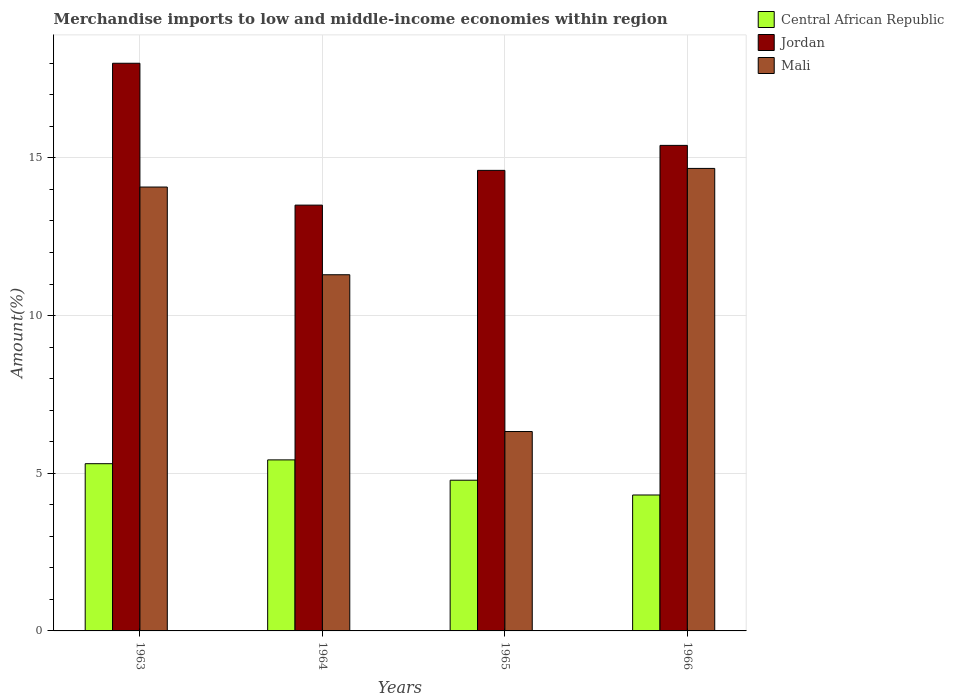How many groups of bars are there?
Your answer should be very brief. 4. Are the number of bars per tick equal to the number of legend labels?
Make the answer very short. Yes. Are the number of bars on each tick of the X-axis equal?
Keep it short and to the point. Yes. How many bars are there on the 1st tick from the right?
Provide a succinct answer. 3. What is the label of the 2nd group of bars from the left?
Offer a very short reply. 1964. In how many cases, is the number of bars for a given year not equal to the number of legend labels?
Make the answer very short. 0. What is the percentage of amount earned from merchandise imports in Jordan in 1965?
Ensure brevity in your answer.  14.6. Across all years, what is the maximum percentage of amount earned from merchandise imports in Jordan?
Make the answer very short. 18. Across all years, what is the minimum percentage of amount earned from merchandise imports in Central African Republic?
Your response must be concise. 4.31. In which year was the percentage of amount earned from merchandise imports in Central African Republic maximum?
Make the answer very short. 1964. In which year was the percentage of amount earned from merchandise imports in Jordan minimum?
Offer a terse response. 1964. What is the total percentage of amount earned from merchandise imports in Mali in the graph?
Give a very brief answer. 46.36. What is the difference between the percentage of amount earned from merchandise imports in Mali in 1963 and that in 1966?
Provide a succinct answer. -0.59. What is the difference between the percentage of amount earned from merchandise imports in Jordan in 1965 and the percentage of amount earned from merchandise imports in Central African Republic in 1963?
Provide a short and direct response. 9.3. What is the average percentage of amount earned from merchandise imports in Central African Republic per year?
Your answer should be very brief. 4.95. In the year 1966, what is the difference between the percentage of amount earned from merchandise imports in Central African Republic and percentage of amount earned from merchandise imports in Jordan?
Provide a short and direct response. -11.09. What is the ratio of the percentage of amount earned from merchandise imports in Mali in 1963 to that in 1966?
Provide a short and direct response. 0.96. Is the percentage of amount earned from merchandise imports in Jordan in 1964 less than that in 1965?
Make the answer very short. Yes. Is the difference between the percentage of amount earned from merchandise imports in Central African Republic in 1963 and 1966 greater than the difference between the percentage of amount earned from merchandise imports in Jordan in 1963 and 1966?
Your answer should be compact. No. What is the difference between the highest and the second highest percentage of amount earned from merchandise imports in Jordan?
Provide a succinct answer. 2.6. What is the difference between the highest and the lowest percentage of amount earned from merchandise imports in Mali?
Your answer should be compact. 8.34. In how many years, is the percentage of amount earned from merchandise imports in Central African Republic greater than the average percentage of amount earned from merchandise imports in Central African Republic taken over all years?
Offer a very short reply. 2. What does the 2nd bar from the left in 1964 represents?
Your answer should be very brief. Jordan. What does the 2nd bar from the right in 1964 represents?
Keep it short and to the point. Jordan. Is it the case that in every year, the sum of the percentage of amount earned from merchandise imports in Central African Republic and percentage of amount earned from merchandise imports in Mali is greater than the percentage of amount earned from merchandise imports in Jordan?
Provide a short and direct response. No. How many bars are there?
Give a very brief answer. 12. Are the values on the major ticks of Y-axis written in scientific E-notation?
Your answer should be compact. No. Does the graph contain any zero values?
Provide a short and direct response. No. Where does the legend appear in the graph?
Make the answer very short. Top right. How are the legend labels stacked?
Ensure brevity in your answer.  Vertical. What is the title of the graph?
Your answer should be compact. Merchandise imports to low and middle-income economies within region. Does "Macedonia" appear as one of the legend labels in the graph?
Ensure brevity in your answer.  No. What is the label or title of the Y-axis?
Make the answer very short. Amount(%). What is the Amount(%) in Central African Republic in 1963?
Offer a very short reply. 5.3. What is the Amount(%) of Jordan in 1963?
Keep it short and to the point. 18. What is the Amount(%) of Mali in 1963?
Your answer should be compact. 14.08. What is the Amount(%) in Central African Republic in 1964?
Give a very brief answer. 5.42. What is the Amount(%) in Jordan in 1964?
Make the answer very short. 13.5. What is the Amount(%) of Mali in 1964?
Provide a succinct answer. 11.29. What is the Amount(%) in Central African Republic in 1965?
Your response must be concise. 4.78. What is the Amount(%) of Jordan in 1965?
Make the answer very short. 14.6. What is the Amount(%) of Mali in 1965?
Your answer should be very brief. 6.32. What is the Amount(%) in Central African Republic in 1966?
Provide a short and direct response. 4.31. What is the Amount(%) of Jordan in 1966?
Offer a terse response. 15.4. What is the Amount(%) in Mali in 1966?
Make the answer very short. 14.67. Across all years, what is the maximum Amount(%) in Central African Republic?
Offer a terse response. 5.42. Across all years, what is the maximum Amount(%) of Jordan?
Make the answer very short. 18. Across all years, what is the maximum Amount(%) of Mali?
Provide a short and direct response. 14.67. Across all years, what is the minimum Amount(%) of Central African Republic?
Offer a terse response. 4.31. Across all years, what is the minimum Amount(%) of Jordan?
Your answer should be compact. 13.5. Across all years, what is the minimum Amount(%) of Mali?
Provide a succinct answer. 6.32. What is the total Amount(%) of Central African Republic in the graph?
Your response must be concise. 19.82. What is the total Amount(%) of Jordan in the graph?
Provide a succinct answer. 61.51. What is the total Amount(%) in Mali in the graph?
Offer a terse response. 46.36. What is the difference between the Amount(%) of Central African Republic in 1963 and that in 1964?
Your response must be concise. -0.12. What is the difference between the Amount(%) in Jordan in 1963 and that in 1964?
Make the answer very short. 4.5. What is the difference between the Amount(%) in Mali in 1963 and that in 1964?
Give a very brief answer. 2.78. What is the difference between the Amount(%) in Central African Republic in 1963 and that in 1965?
Give a very brief answer. 0.52. What is the difference between the Amount(%) in Jordan in 1963 and that in 1965?
Your answer should be very brief. 3.4. What is the difference between the Amount(%) of Mali in 1963 and that in 1965?
Offer a terse response. 7.75. What is the difference between the Amount(%) of Jordan in 1963 and that in 1966?
Your answer should be compact. 2.6. What is the difference between the Amount(%) of Mali in 1963 and that in 1966?
Offer a terse response. -0.59. What is the difference between the Amount(%) of Central African Republic in 1964 and that in 1965?
Your response must be concise. 0.64. What is the difference between the Amount(%) in Jordan in 1964 and that in 1965?
Give a very brief answer. -1.1. What is the difference between the Amount(%) of Mali in 1964 and that in 1965?
Ensure brevity in your answer.  4.97. What is the difference between the Amount(%) in Central African Republic in 1964 and that in 1966?
Provide a short and direct response. 1.11. What is the difference between the Amount(%) of Jordan in 1964 and that in 1966?
Give a very brief answer. -1.89. What is the difference between the Amount(%) in Mali in 1964 and that in 1966?
Give a very brief answer. -3.37. What is the difference between the Amount(%) in Central African Republic in 1965 and that in 1966?
Make the answer very short. 0.47. What is the difference between the Amount(%) in Jordan in 1965 and that in 1966?
Ensure brevity in your answer.  -0.79. What is the difference between the Amount(%) in Mali in 1965 and that in 1966?
Your answer should be compact. -8.34. What is the difference between the Amount(%) in Central African Republic in 1963 and the Amount(%) in Jordan in 1964?
Keep it short and to the point. -8.2. What is the difference between the Amount(%) in Central African Republic in 1963 and the Amount(%) in Mali in 1964?
Your answer should be very brief. -5.99. What is the difference between the Amount(%) of Jordan in 1963 and the Amount(%) of Mali in 1964?
Your answer should be compact. 6.71. What is the difference between the Amount(%) in Central African Republic in 1963 and the Amount(%) in Jordan in 1965?
Your answer should be compact. -9.3. What is the difference between the Amount(%) of Central African Republic in 1963 and the Amount(%) of Mali in 1965?
Offer a terse response. -1.02. What is the difference between the Amount(%) of Jordan in 1963 and the Amount(%) of Mali in 1965?
Keep it short and to the point. 11.68. What is the difference between the Amount(%) in Central African Republic in 1963 and the Amount(%) in Jordan in 1966?
Provide a succinct answer. -10.09. What is the difference between the Amount(%) in Central African Republic in 1963 and the Amount(%) in Mali in 1966?
Ensure brevity in your answer.  -9.36. What is the difference between the Amount(%) of Jordan in 1963 and the Amount(%) of Mali in 1966?
Provide a short and direct response. 3.33. What is the difference between the Amount(%) in Central African Republic in 1964 and the Amount(%) in Jordan in 1965?
Offer a very short reply. -9.18. What is the difference between the Amount(%) in Central African Republic in 1964 and the Amount(%) in Mali in 1965?
Give a very brief answer. -0.9. What is the difference between the Amount(%) of Jordan in 1964 and the Amount(%) of Mali in 1965?
Your response must be concise. 7.18. What is the difference between the Amount(%) in Central African Republic in 1964 and the Amount(%) in Jordan in 1966?
Provide a short and direct response. -9.97. What is the difference between the Amount(%) in Central African Republic in 1964 and the Amount(%) in Mali in 1966?
Make the answer very short. -9.24. What is the difference between the Amount(%) in Jordan in 1964 and the Amount(%) in Mali in 1966?
Offer a very short reply. -1.16. What is the difference between the Amount(%) in Central African Republic in 1965 and the Amount(%) in Jordan in 1966?
Your response must be concise. -10.62. What is the difference between the Amount(%) of Central African Republic in 1965 and the Amount(%) of Mali in 1966?
Keep it short and to the point. -9.89. What is the difference between the Amount(%) in Jordan in 1965 and the Amount(%) in Mali in 1966?
Keep it short and to the point. -0.06. What is the average Amount(%) in Central African Republic per year?
Your answer should be compact. 4.95. What is the average Amount(%) of Jordan per year?
Provide a short and direct response. 15.38. What is the average Amount(%) of Mali per year?
Your answer should be compact. 11.59. In the year 1963, what is the difference between the Amount(%) of Central African Republic and Amount(%) of Jordan?
Ensure brevity in your answer.  -12.7. In the year 1963, what is the difference between the Amount(%) of Central African Republic and Amount(%) of Mali?
Your answer should be compact. -8.77. In the year 1963, what is the difference between the Amount(%) in Jordan and Amount(%) in Mali?
Give a very brief answer. 3.93. In the year 1964, what is the difference between the Amount(%) in Central African Republic and Amount(%) in Jordan?
Your answer should be very brief. -8.08. In the year 1964, what is the difference between the Amount(%) of Central African Republic and Amount(%) of Mali?
Your answer should be very brief. -5.87. In the year 1964, what is the difference between the Amount(%) in Jordan and Amount(%) in Mali?
Provide a short and direct response. 2.21. In the year 1965, what is the difference between the Amount(%) in Central African Republic and Amount(%) in Jordan?
Make the answer very short. -9.83. In the year 1965, what is the difference between the Amount(%) of Central African Republic and Amount(%) of Mali?
Your answer should be compact. -1.54. In the year 1965, what is the difference between the Amount(%) of Jordan and Amount(%) of Mali?
Your response must be concise. 8.28. In the year 1966, what is the difference between the Amount(%) in Central African Republic and Amount(%) in Jordan?
Keep it short and to the point. -11.09. In the year 1966, what is the difference between the Amount(%) of Central African Republic and Amount(%) of Mali?
Offer a very short reply. -10.36. In the year 1966, what is the difference between the Amount(%) in Jordan and Amount(%) in Mali?
Provide a short and direct response. 0.73. What is the ratio of the Amount(%) in Central African Republic in 1963 to that in 1964?
Offer a very short reply. 0.98. What is the ratio of the Amount(%) of Jordan in 1963 to that in 1964?
Offer a very short reply. 1.33. What is the ratio of the Amount(%) in Mali in 1963 to that in 1964?
Your response must be concise. 1.25. What is the ratio of the Amount(%) in Central African Republic in 1963 to that in 1965?
Offer a terse response. 1.11. What is the ratio of the Amount(%) of Jordan in 1963 to that in 1965?
Your answer should be compact. 1.23. What is the ratio of the Amount(%) of Mali in 1963 to that in 1965?
Your answer should be compact. 2.23. What is the ratio of the Amount(%) of Central African Republic in 1963 to that in 1966?
Give a very brief answer. 1.23. What is the ratio of the Amount(%) in Jordan in 1963 to that in 1966?
Ensure brevity in your answer.  1.17. What is the ratio of the Amount(%) of Mali in 1963 to that in 1966?
Offer a very short reply. 0.96. What is the ratio of the Amount(%) of Central African Republic in 1964 to that in 1965?
Provide a succinct answer. 1.13. What is the ratio of the Amount(%) of Jordan in 1964 to that in 1965?
Your response must be concise. 0.92. What is the ratio of the Amount(%) in Mali in 1964 to that in 1965?
Make the answer very short. 1.79. What is the ratio of the Amount(%) in Central African Republic in 1964 to that in 1966?
Give a very brief answer. 1.26. What is the ratio of the Amount(%) of Jordan in 1964 to that in 1966?
Your response must be concise. 0.88. What is the ratio of the Amount(%) in Mali in 1964 to that in 1966?
Ensure brevity in your answer.  0.77. What is the ratio of the Amount(%) in Central African Republic in 1965 to that in 1966?
Your answer should be very brief. 1.11. What is the ratio of the Amount(%) in Jordan in 1965 to that in 1966?
Your answer should be compact. 0.95. What is the ratio of the Amount(%) of Mali in 1965 to that in 1966?
Provide a succinct answer. 0.43. What is the difference between the highest and the second highest Amount(%) of Central African Republic?
Your answer should be very brief. 0.12. What is the difference between the highest and the second highest Amount(%) in Jordan?
Provide a short and direct response. 2.6. What is the difference between the highest and the second highest Amount(%) of Mali?
Give a very brief answer. 0.59. What is the difference between the highest and the lowest Amount(%) of Central African Republic?
Offer a very short reply. 1.11. What is the difference between the highest and the lowest Amount(%) in Jordan?
Provide a succinct answer. 4.5. What is the difference between the highest and the lowest Amount(%) of Mali?
Ensure brevity in your answer.  8.34. 